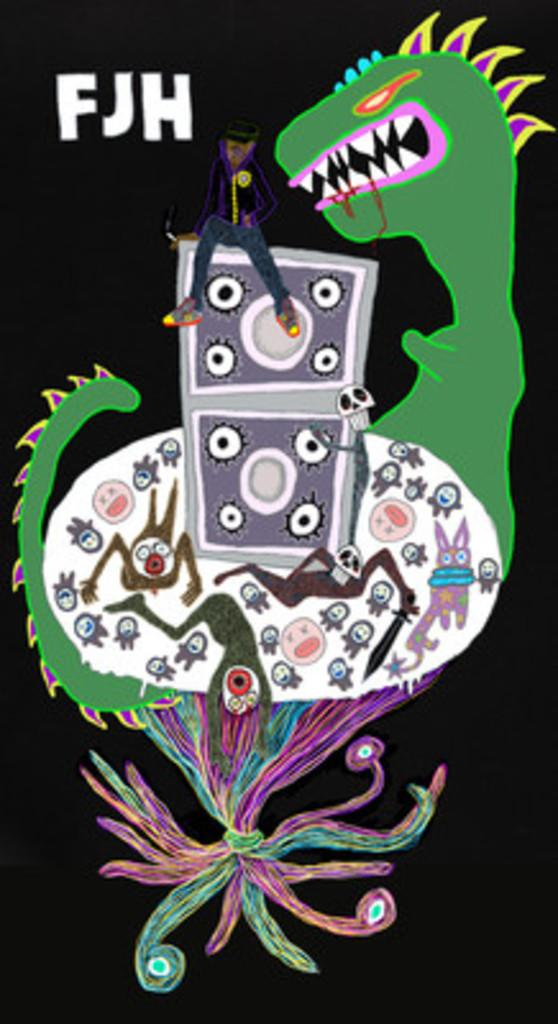What type of image is shown in the picture? The image is animated. What other elements can be found in the animated image? There is text present in the image, and there are other images within the animated image. How many mice can be seen running around in the image? There are no mice present in the image. What time does the clock in the image show? There is no clock present in the image. 